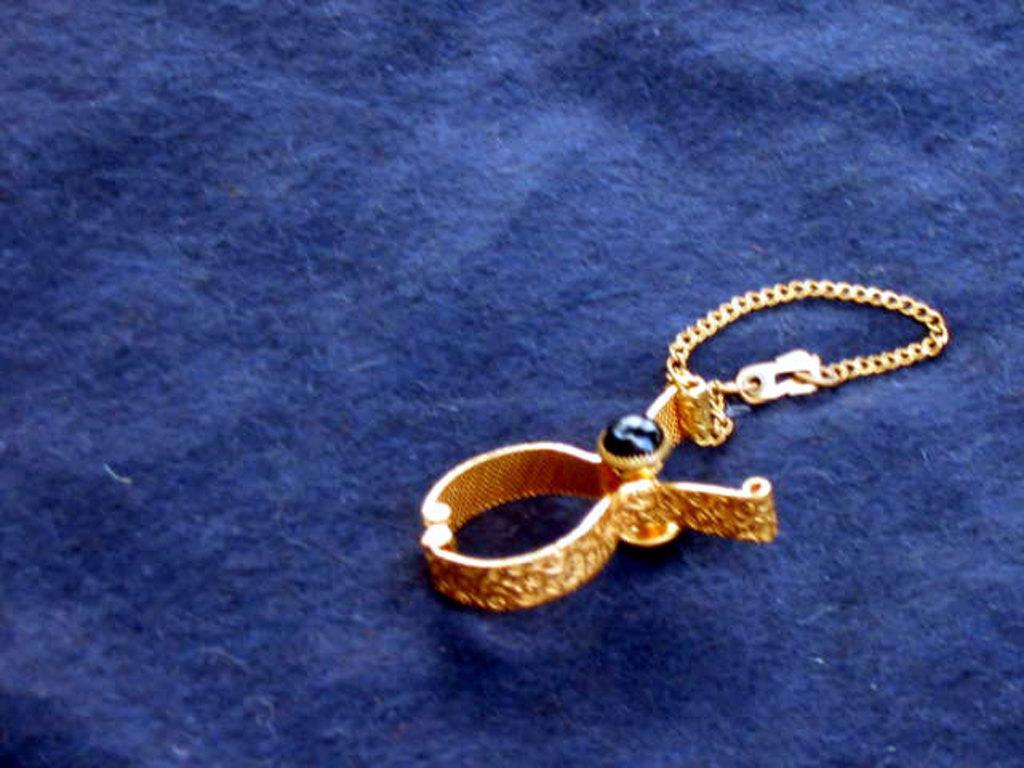Can you describe this image briefly? In this picture we can see an ornament on a platform. 